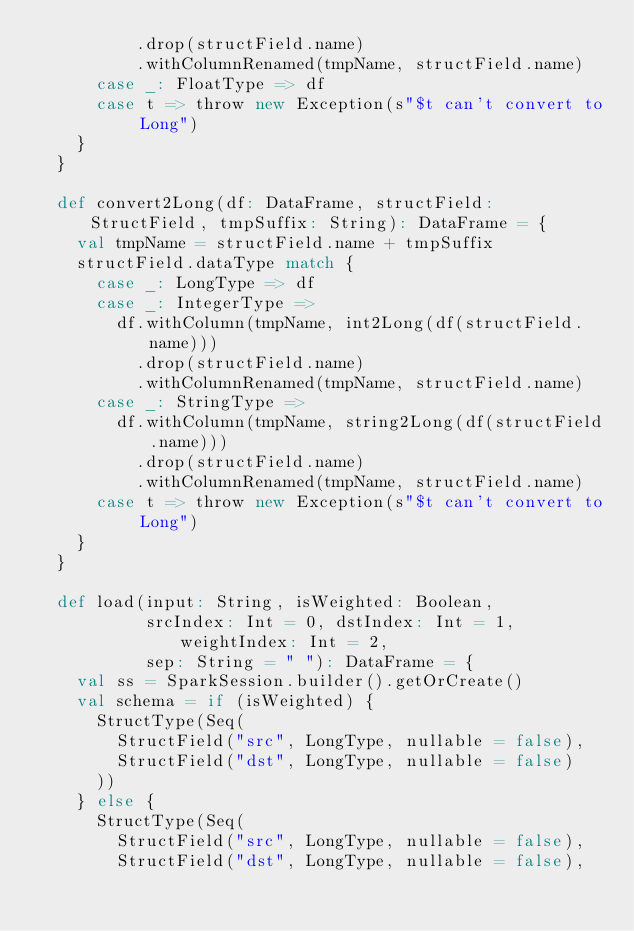Convert code to text. <code><loc_0><loc_0><loc_500><loc_500><_Scala_>          .drop(structField.name)
          .withColumnRenamed(tmpName, structField.name)
      case _: FloatType => df
      case t => throw new Exception(s"$t can't convert to Long")
    }
  }

  def convert2Long(df: DataFrame, structField: StructField, tmpSuffix: String): DataFrame = {
    val tmpName = structField.name + tmpSuffix
    structField.dataType match {
      case _: LongType => df
      case _: IntegerType =>
        df.withColumn(tmpName, int2Long(df(structField.name)))
          .drop(structField.name)
          .withColumnRenamed(tmpName, structField.name)
      case _: StringType =>
        df.withColumn(tmpName, string2Long(df(structField.name)))
          .drop(structField.name)
          .withColumnRenamed(tmpName, structField.name)
      case t => throw new Exception(s"$t can't convert to Long")
    }
  }

  def load(input: String, isWeighted: Boolean,
           srcIndex: Int = 0, dstIndex: Int = 1, weightIndex: Int = 2,
           sep: String = " "): DataFrame = {
    val ss = SparkSession.builder().getOrCreate()
    val schema = if (isWeighted) {
      StructType(Seq(
        StructField("src", LongType, nullable = false),
        StructField("dst", LongType, nullable = false)
      ))
    } else {
      StructType(Seq(
        StructField("src", LongType, nullable = false),
        StructField("dst", LongType, nullable = false),</code> 